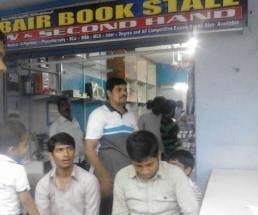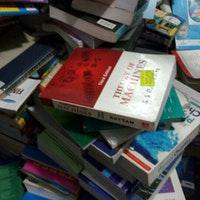The first image is the image on the left, the second image is the image on the right. Assess this claim about the two images: "One image has a man facing left and looking down.". Correct or not? Answer yes or no. No. 